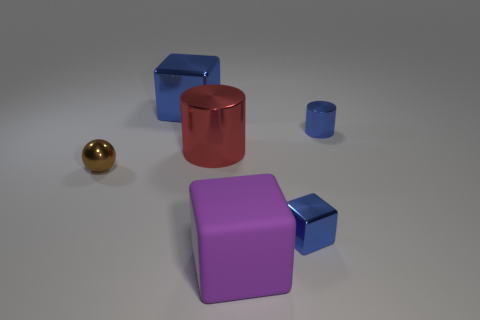Is there any other thing that has the same material as the purple object?
Offer a terse response. No. Are there any shiny cylinders that have the same color as the tiny cube?
Make the answer very short. Yes. Do the purple cube in front of the small brown metal ball and the small brown sphere have the same material?
Offer a terse response. No. What material is the tiny blue object that is the same shape as the big rubber object?
Provide a succinct answer. Metal. There is a metal block that is in front of the blue block behind the red metallic thing; are there any cubes that are in front of it?
Keep it short and to the point. Yes. Is the shape of the small blue metallic thing behind the big red object the same as the tiny brown object behind the small cube?
Make the answer very short. No. Is the number of small blue metallic things left of the small metal cylinder greater than the number of small cyan matte cylinders?
Your answer should be very brief. Yes. How many objects are either big yellow matte cubes or large purple blocks?
Offer a very short reply. 1. What is the color of the large metal cube?
Make the answer very short. Blue. How many other objects are there of the same color as the small metal cylinder?
Offer a very short reply. 2. 